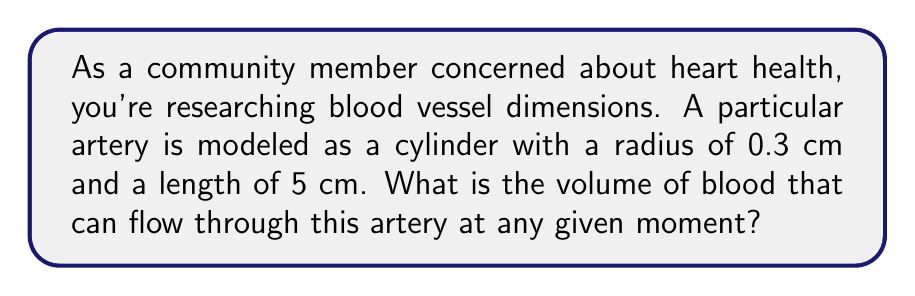Teach me how to tackle this problem. To solve this problem, we need to use the formula for the volume of a cylinder:

$$V = \pi r^2 h$$

Where:
$V$ = volume
$r$ = radius of the base
$h$ = height (length) of the cylinder

Given:
$r = 0.3$ cm
$h = 5$ cm

Let's substitute these values into the formula:

$$V = \pi (0.3\text{ cm})^2 (5\text{ cm})$$

Now, let's calculate step by step:

1) First, calculate $r^2$:
   $$(0.3\text{ cm})^2 = 0.09\text{ cm}^2$$

2) Multiply by $\pi$:
   $$\pi(0.09\text{ cm}^2) \approx 0.2827\text{ cm}^2$$

3) Finally, multiply by the height:
   $$(0.2827\text{ cm}^2)(5\text{ cm}) \approx 1.4137\text{ cm}^3$$

Therefore, the volume of the blood vessel is approximately 1.4137 cubic centimeters.
Answer: $1.4137\text{ cm}^3$ 